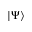<formula> <loc_0><loc_0><loc_500><loc_500>| \Psi \rangle</formula> 